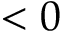Convert formula to latex. <formula><loc_0><loc_0><loc_500><loc_500>< 0</formula> 